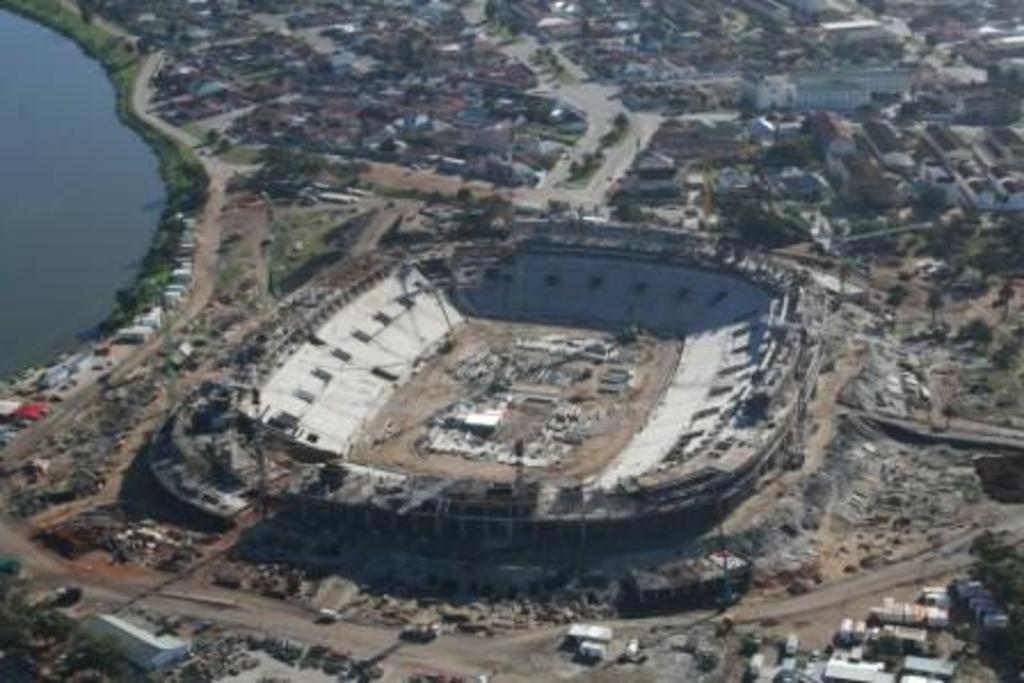What type of structures can be seen in the image? There are buildings in the image. What type of vegetation is present in the image? There are trees in the image. What natural element is visible in the image? There is water visible in the image. What flavor of pipe can be seen in the image? There is no pipe present in the image, and therefore no flavor can be associated with it. 